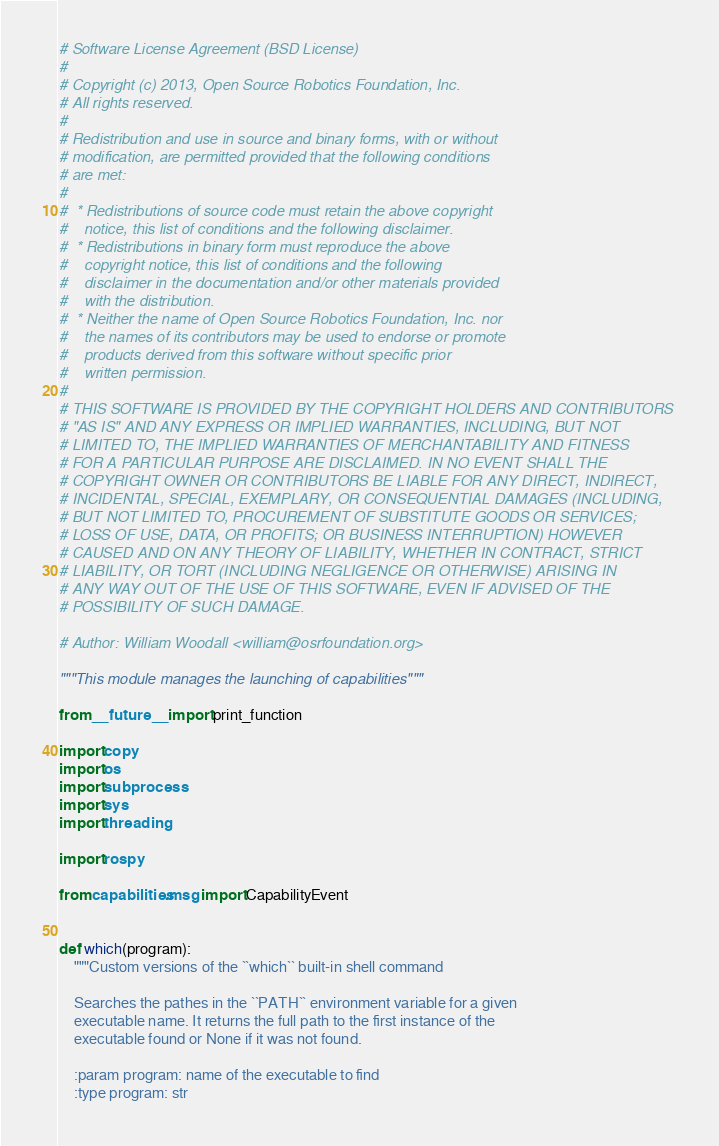<code> <loc_0><loc_0><loc_500><loc_500><_Python_># Software License Agreement (BSD License)
#
# Copyright (c) 2013, Open Source Robotics Foundation, Inc.
# All rights reserved.
#
# Redistribution and use in source and binary forms, with or without
# modification, are permitted provided that the following conditions
# are met:
#
#  * Redistributions of source code must retain the above copyright
#    notice, this list of conditions and the following disclaimer.
#  * Redistributions in binary form must reproduce the above
#    copyright notice, this list of conditions and the following
#    disclaimer in the documentation and/or other materials provided
#    with the distribution.
#  * Neither the name of Open Source Robotics Foundation, Inc. nor
#    the names of its contributors may be used to endorse or promote
#    products derived from this software without specific prior
#    written permission.
#
# THIS SOFTWARE IS PROVIDED BY THE COPYRIGHT HOLDERS AND CONTRIBUTORS
# "AS IS" AND ANY EXPRESS OR IMPLIED WARRANTIES, INCLUDING, BUT NOT
# LIMITED TO, THE IMPLIED WARRANTIES OF MERCHANTABILITY AND FITNESS
# FOR A PARTICULAR PURPOSE ARE DISCLAIMED. IN NO EVENT SHALL THE
# COPYRIGHT OWNER OR CONTRIBUTORS BE LIABLE FOR ANY DIRECT, INDIRECT,
# INCIDENTAL, SPECIAL, EXEMPLARY, OR CONSEQUENTIAL DAMAGES (INCLUDING,
# BUT NOT LIMITED TO, PROCUREMENT OF SUBSTITUTE GOODS OR SERVICES;
# LOSS OF USE, DATA, OR PROFITS; OR BUSINESS INTERRUPTION) HOWEVER
# CAUSED AND ON ANY THEORY OF LIABILITY, WHETHER IN CONTRACT, STRICT
# LIABILITY, OR TORT (INCLUDING NEGLIGENCE OR OTHERWISE) ARISING IN
# ANY WAY OUT OF THE USE OF THIS SOFTWARE, EVEN IF ADVISED OF THE
# POSSIBILITY OF SUCH DAMAGE.

# Author: William Woodall <william@osrfoundation.org>

"""This module manages the launching of capabilities"""

from __future__ import print_function

import copy
import os
import subprocess
import sys
import threading

import rospy

from capabilities.msg import CapabilityEvent


def which(program):
    """Custom versions of the ``which`` built-in shell command

    Searches the pathes in the ``PATH`` environment variable for a given
    executable name. It returns the full path to the first instance of the
    executable found or None if it was not found.

    :param program: name of the executable to find
    :type program: str</code> 